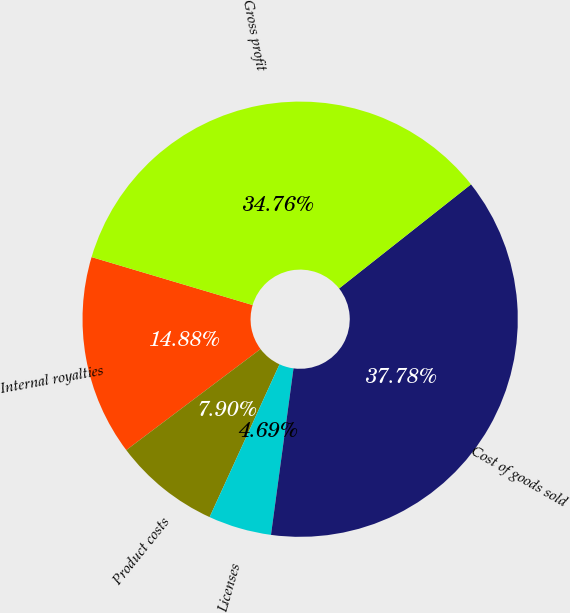<chart> <loc_0><loc_0><loc_500><loc_500><pie_chart><fcel>Internal royalties<fcel>Product costs<fcel>Licenses<fcel>Cost of goods sold<fcel>Gross profit<nl><fcel>14.88%<fcel>7.9%<fcel>4.69%<fcel>37.78%<fcel>34.76%<nl></chart> 